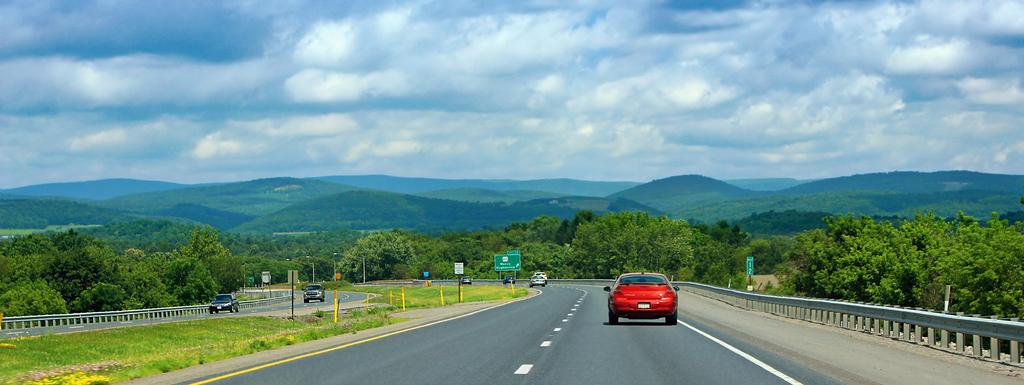What can be seen on the road in the image? There are vehicles on the road in the image. What type of natural elements can be seen in the background of the image? There are trees visible in the background of the image. What is visible in the sky in the background of the image? Clouds are present in the sky in the background of the image. Where is the waste disposal area located in the image? There is no waste disposal area present in the image. What type of animal can be seen playing with a cub in the image? There are no animals or cubs present in the image. 